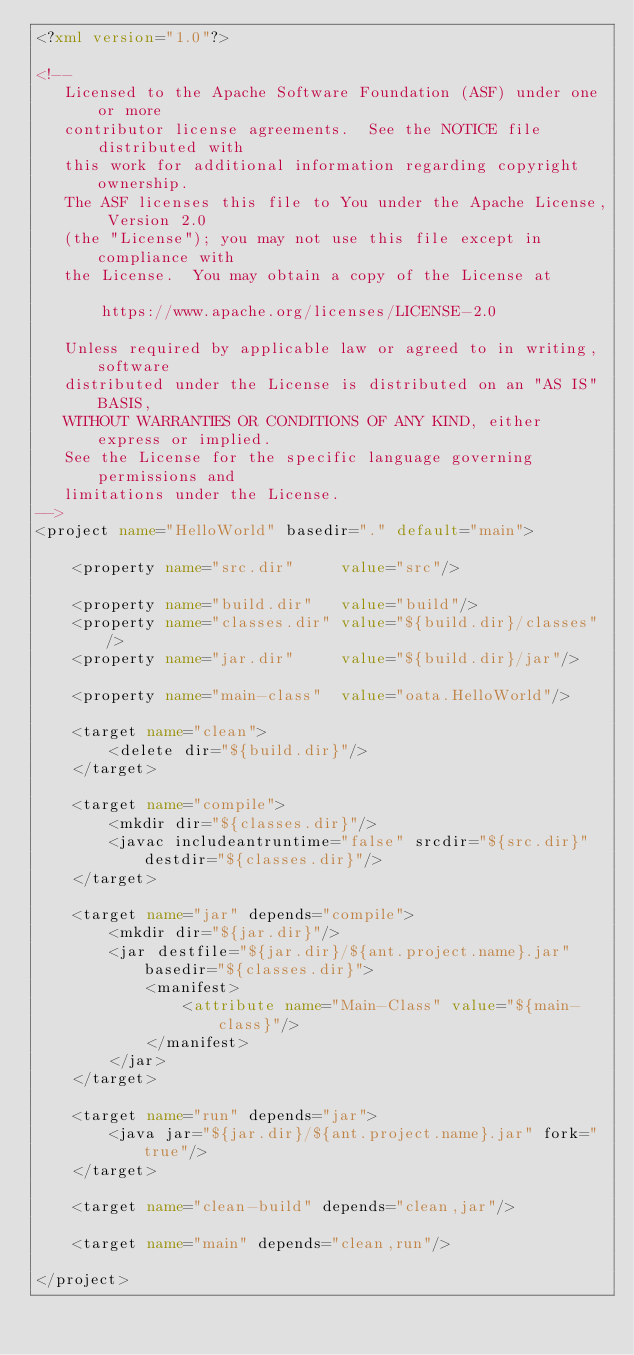Convert code to text. <code><loc_0><loc_0><loc_500><loc_500><_XML_><?xml version="1.0"?>

<!--
   Licensed to the Apache Software Foundation (ASF) under one or more
   contributor license agreements.  See the NOTICE file distributed with
   this work for additional information regarding copyright ownership.
   The ASF licenses this file to You under the Apache License, Version 2.0
   (the "License"); you may not use this file except in compliance with
   the License.  You may obtain a copy of the License at

       https://www.apache.org/licenses/LICENSE-2.0

   Unless required by applicable law or agreed to in writing, software
   distributed under the License is distributed on an "AS IS" BASIS,
   WITHOUT WARRANTIES OR CONDITIONS OF ANY KIND, either express or implied.
   See the License for the specific language governing permissions and
   limitations under the License.
-->
<project name="HelloWorld" basedir="." default="main">

    <property name="src.dir"     value="src"/>

    <property name="build.dir"   value="build"/>
    <property name="classes.dir" value="${build.dir}/classes"/>
    <property name="jar.dir"     value="${build.dir}/jar"/>

    <property name="main-class"  value="oata.HelloWorld"/>

    <target name="clean">
        <delete dir="${build.dir}"/>
    </target>

    <target name="compile">
        <mkdir dir="${classes.dir}"/>
        <javac includeantruntime="false" srcdir="${src.dir}" destdir="${classes.dir}"/>
    </target>

    <target name="jar" depends="compile">
        <mkdir dir="${jar.dir}"/>
        <jar destfile="${jar.dir}/${ant.project.name}.jar" basedir="${classes.dir}">
            <manifest>
                <attribute name="Main-Class" value="${main-class}"/>
            </manifest>
        </jar>
    </target>

    <target name="run" depends="jar">
        <java jar="${jar.dir}/${ant.project.name}.jar" fork="true"/>
    </target>

    <target name="clean-build" depends="clean,jar"/>

    <target name="main" depends="clean,run"/>

</project>
</code> 